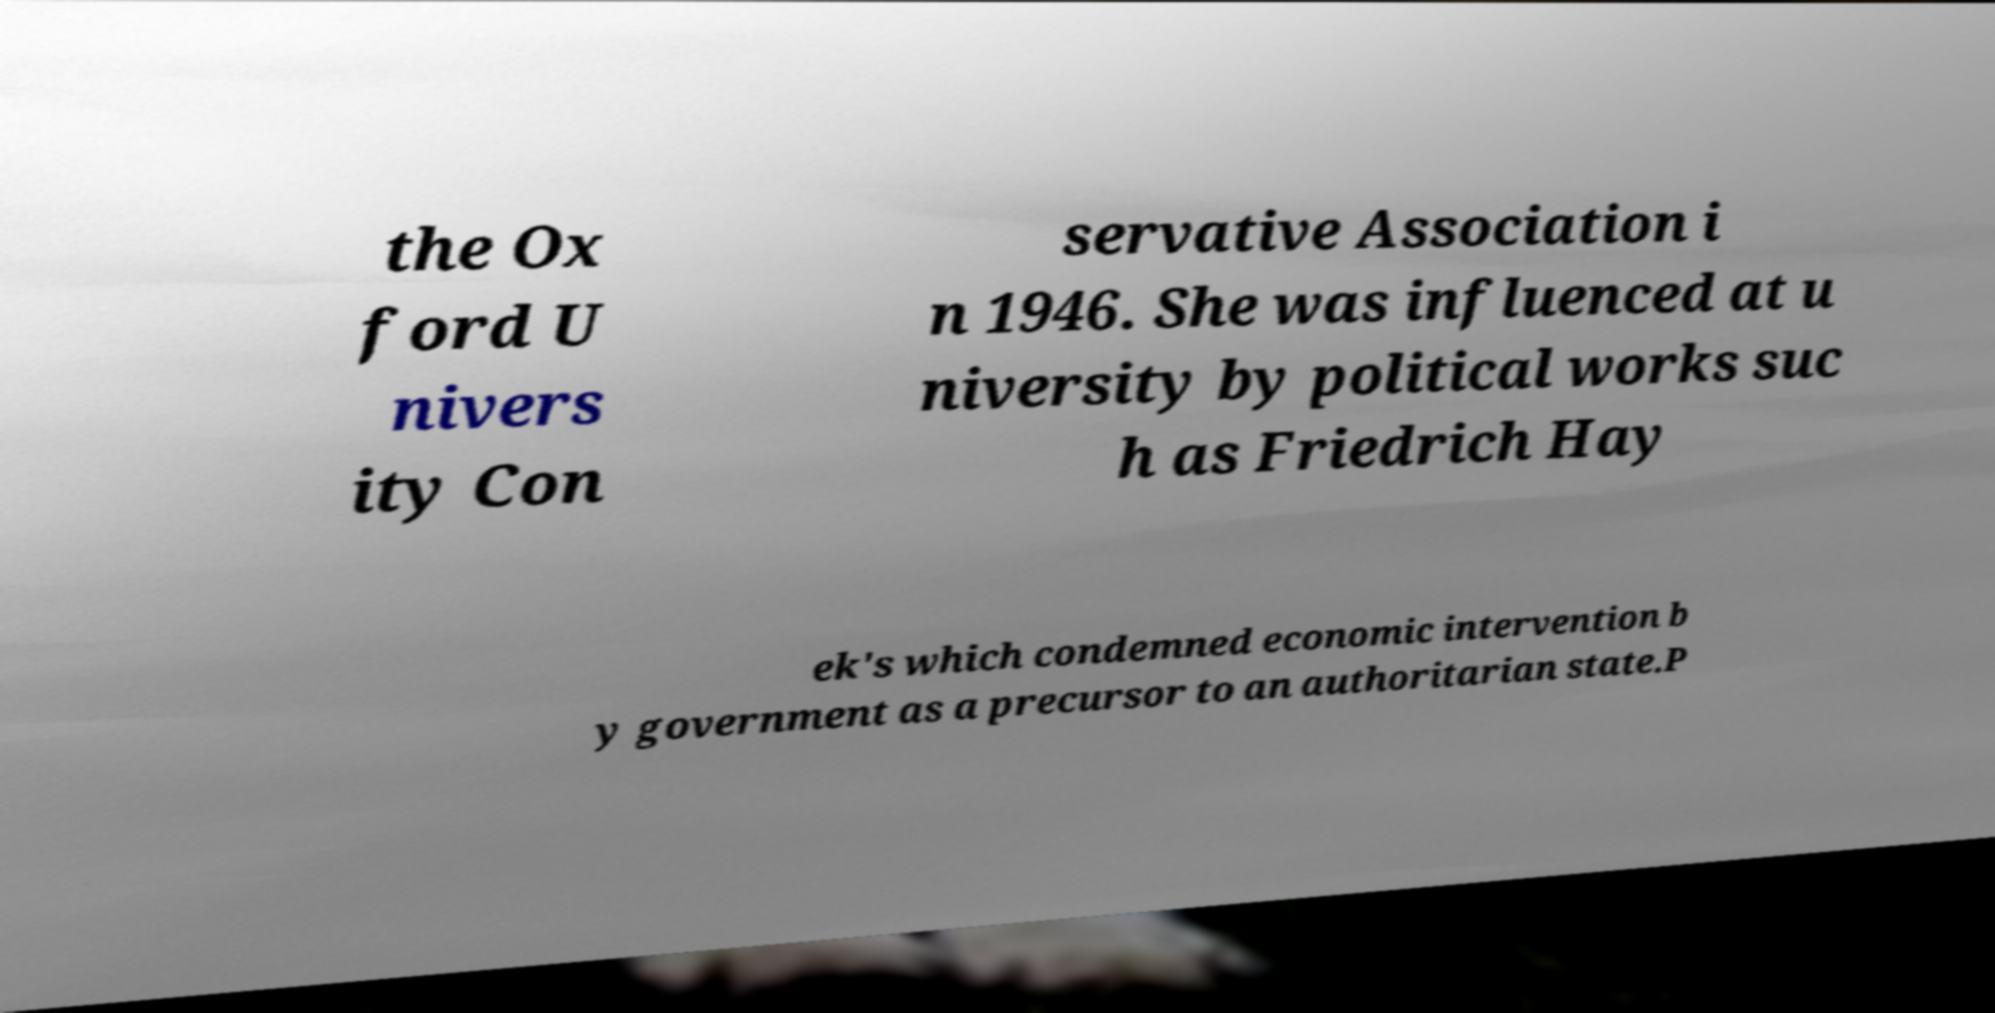Could you assist in decoding the text presented in this image and type it out clearly? the Ox ford U nivers ity Con servative Association i n 1946. She was influenced at u niversity by political works suc h as Friedrich Hay ek's which condemned economic intervention b y government as a precursor to an authoritarian state.P 